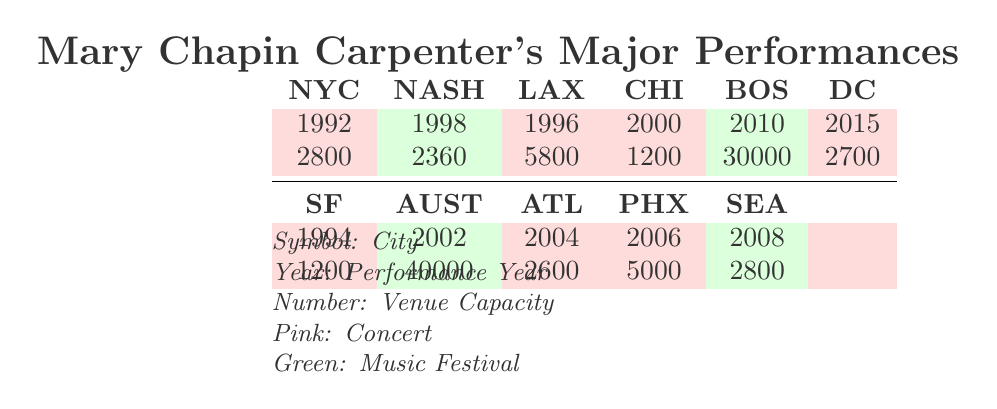What year did Mary Chapin Carpenter perform in New York City? The table shows that she performed in New York City in 1992.
Answer: 1992 What is the capacity of the venue where she performed in Boston? According to the table, the capacity of the venue in Boston (Boston Common) is 30000.
Answer: 30000 How many concerts did she perform in cities that have a capacity greater than 4000? The venues with a capacity greater than 4000 are Los Angeles (5800) and Boston (30000). Therefore, there are 2 concerts that satisfy this condition.
Answer: 2 Was the performance in Nashville part of a music festival? The table indicates that the performance in Nashville was categorized as a Music Festival, so the answer is yes.
Answer: Yes Which concert had the smallest venue capacity and where was it held? The table lists Chicago at House of Blues with a venue capacity of 1200, which is the smallest capacity.
Answer: Chicago, 1200 What is the total capacity of all the concert venues where she performed? The concert venues listed are: New York City (2800), Los Angeles (5800), Chicago (1200), Washington D.C. (2700), Atlanta (2600), Phoenix (5000), and Seattle (2800). Adding these together: 2800 + 5800 + 1200 + 2700 + 2600 + 5000 + 2800 = 19700.
Answer: 19700 Did she ever perform in a venue with a capacity of 40000? Yes, the table shows that in Austin, the venue's capacity was 40000 during the performance in 2002.
Answer: Yes What was the trend in concert locations over the years? The early performances (1992 to 1998) were mainly in the East Coast and Midwest, while later performances (2000s) included other regions like the West Coast and the South.
Answer: East Coast to broader locations How many concerts did she perform after the year 2000? Referring to the table, the concerts after 2000 are in 2002 (Austin), 2004 (Atlanta), 2006 (Phoenix), and 2008 (Seattle), which sums up to 4 concerts.
Answer: 4 